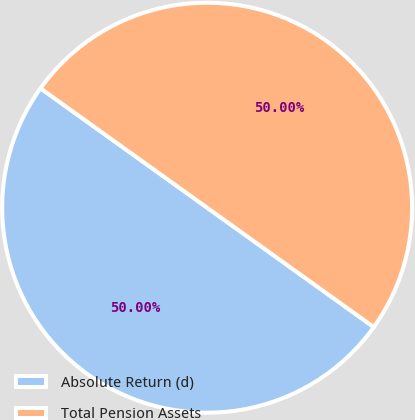Convert chart. <chart><loc_0><loc_0><loc_500><loc_500><pie_chart><fcel>Absolute Return (d)<fcel>Total Pension Assets<nl><fcel>50.0%<fcel>50.0%<nl></chart> 